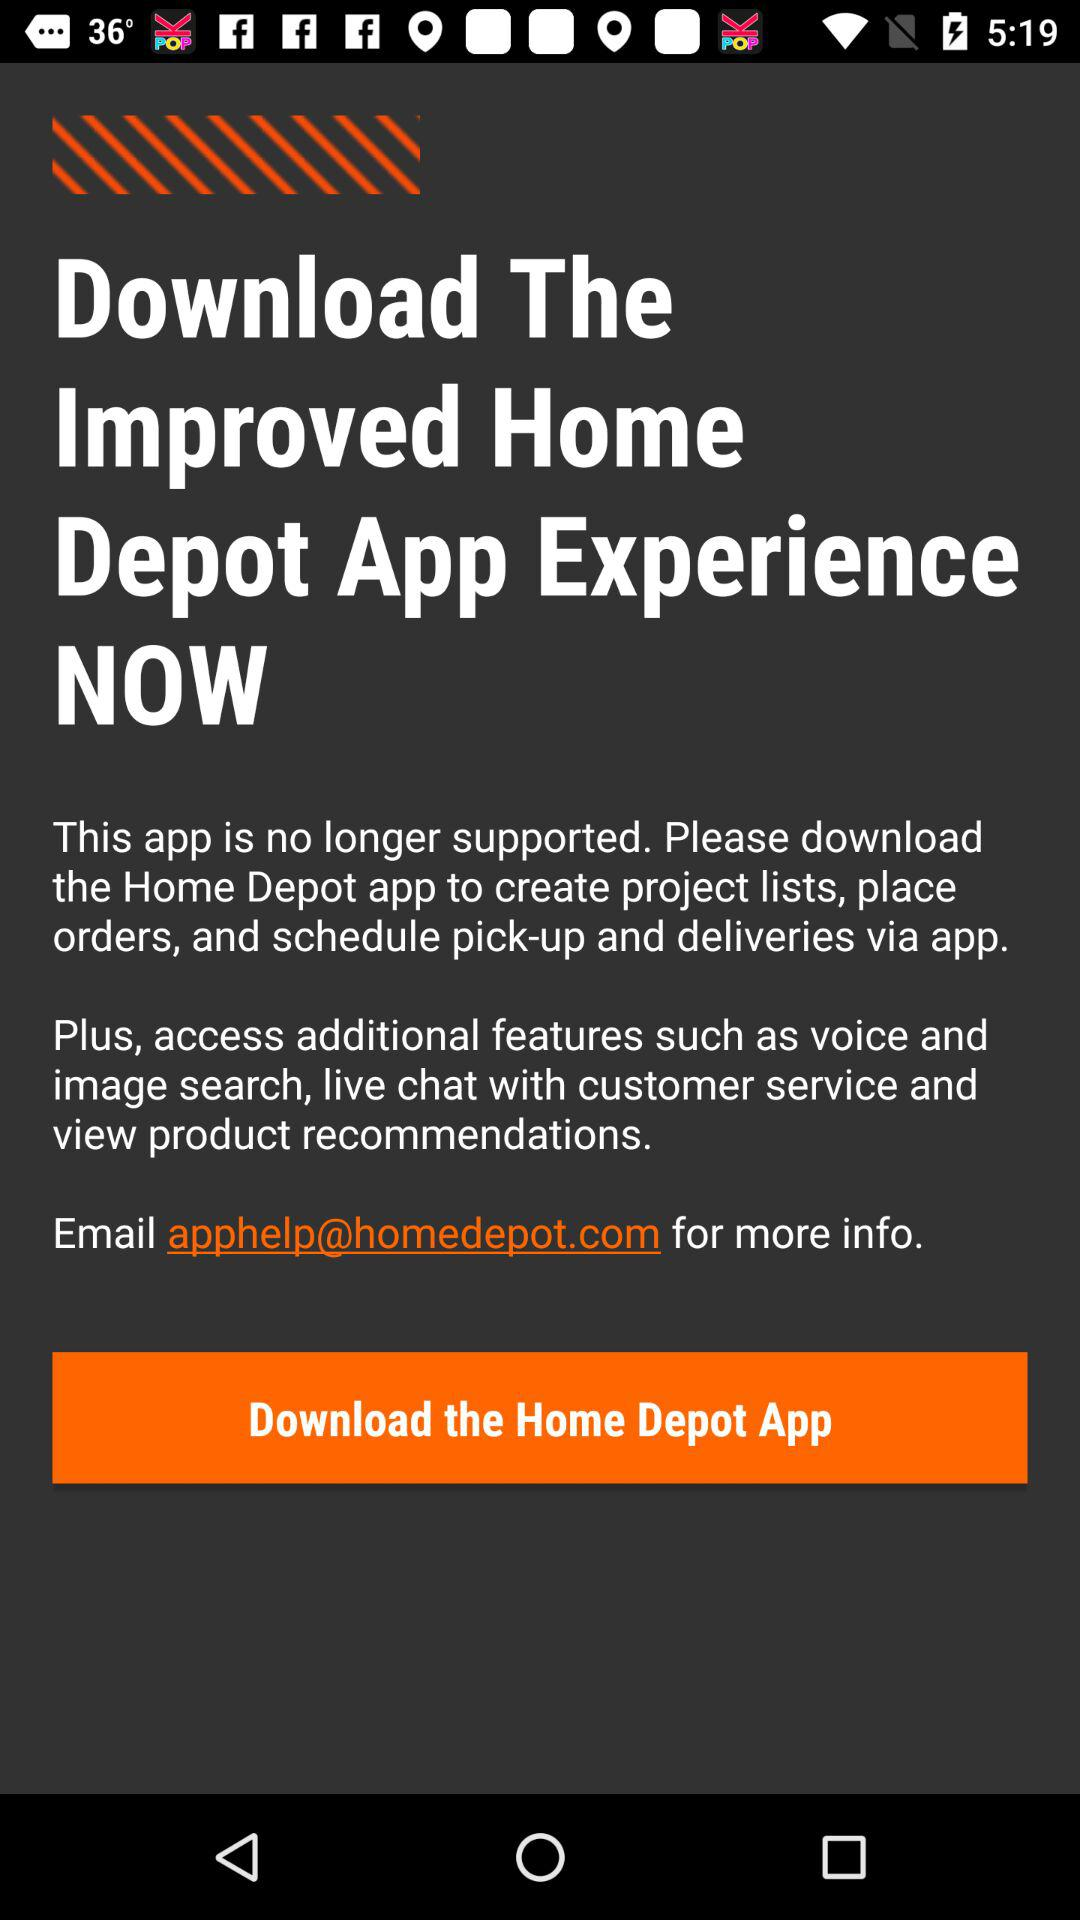What is the shown email address? The shown email address is apphelp@homedepot.com. 